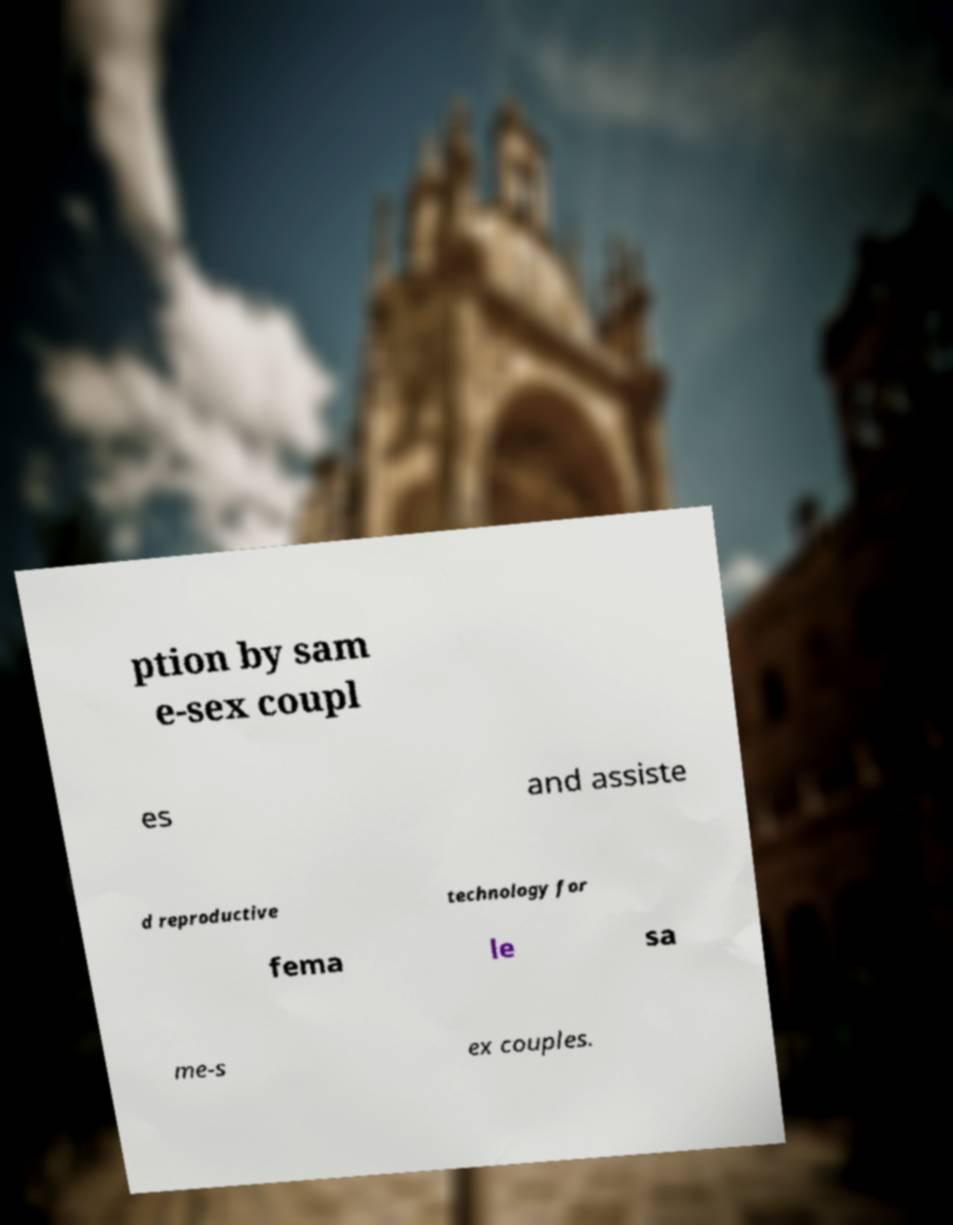I need the written content from this picture converted into text. Can you do that? ption by sam e-sex coupl es and assiste d reproductive technology for fema le sa me-s ex couples. 